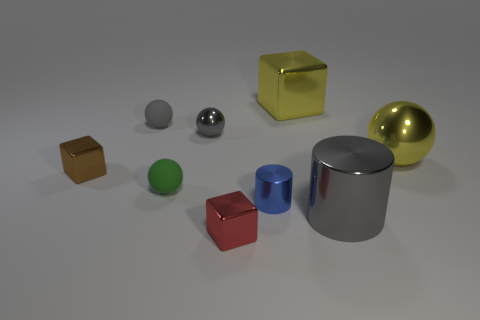Are there an equal number of balls that are in front of the small green object and yellow balls that are to the right of the red object?
Provide a succinct answer. No. There is a tiny object right of the small red cube; is its shape the same as the gray thing to the right of the red shiny thing?
Offer a terse response. Yes. Are there any other things that are the same shape as the brown shiny thing?
Provide a short and direct response. Yes. There is a blue thing that is the same material as the tiny red object; what is its shape?
Ensure brevity in your answer.  Cylinder. Are there an equal number of objects behind the tiny metal ball and small purple metal cylinders?
Your response must be concise. No. Do the gray thing that is on the right side of the small blue object and the small cube right of the gray shiny sphere have the same material?
Make the answer very short. Yes. There is a matte object that is in front of the gray object behind the tiny metallic ball; what is its shape?
Offer a very short reply. Sphere. There is a big sphere that is the same material as the brown object; what is its color?
Your answer should be very brief. Yellow. Is the number of brown metallic objects the same as the number of things?
Offer a very short reply. No. Is the color of the small metal cylinder the same as the big ball?
Your response must be concise. No. 